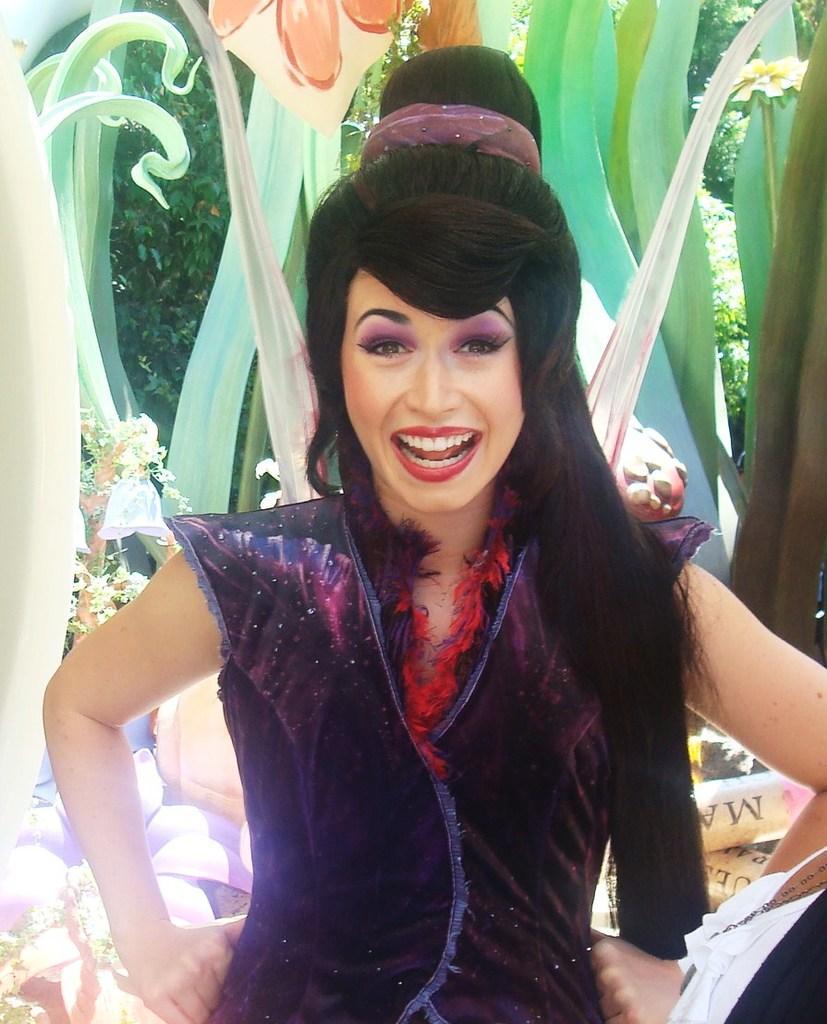Describe this image in one or two sentences. In this image I can see a woman in the front and I can see she is wearing black colour dress. In the background I can see few green colour things and number of trees. On the bottom right side of this image I can see few things and on it I can see something is written. 